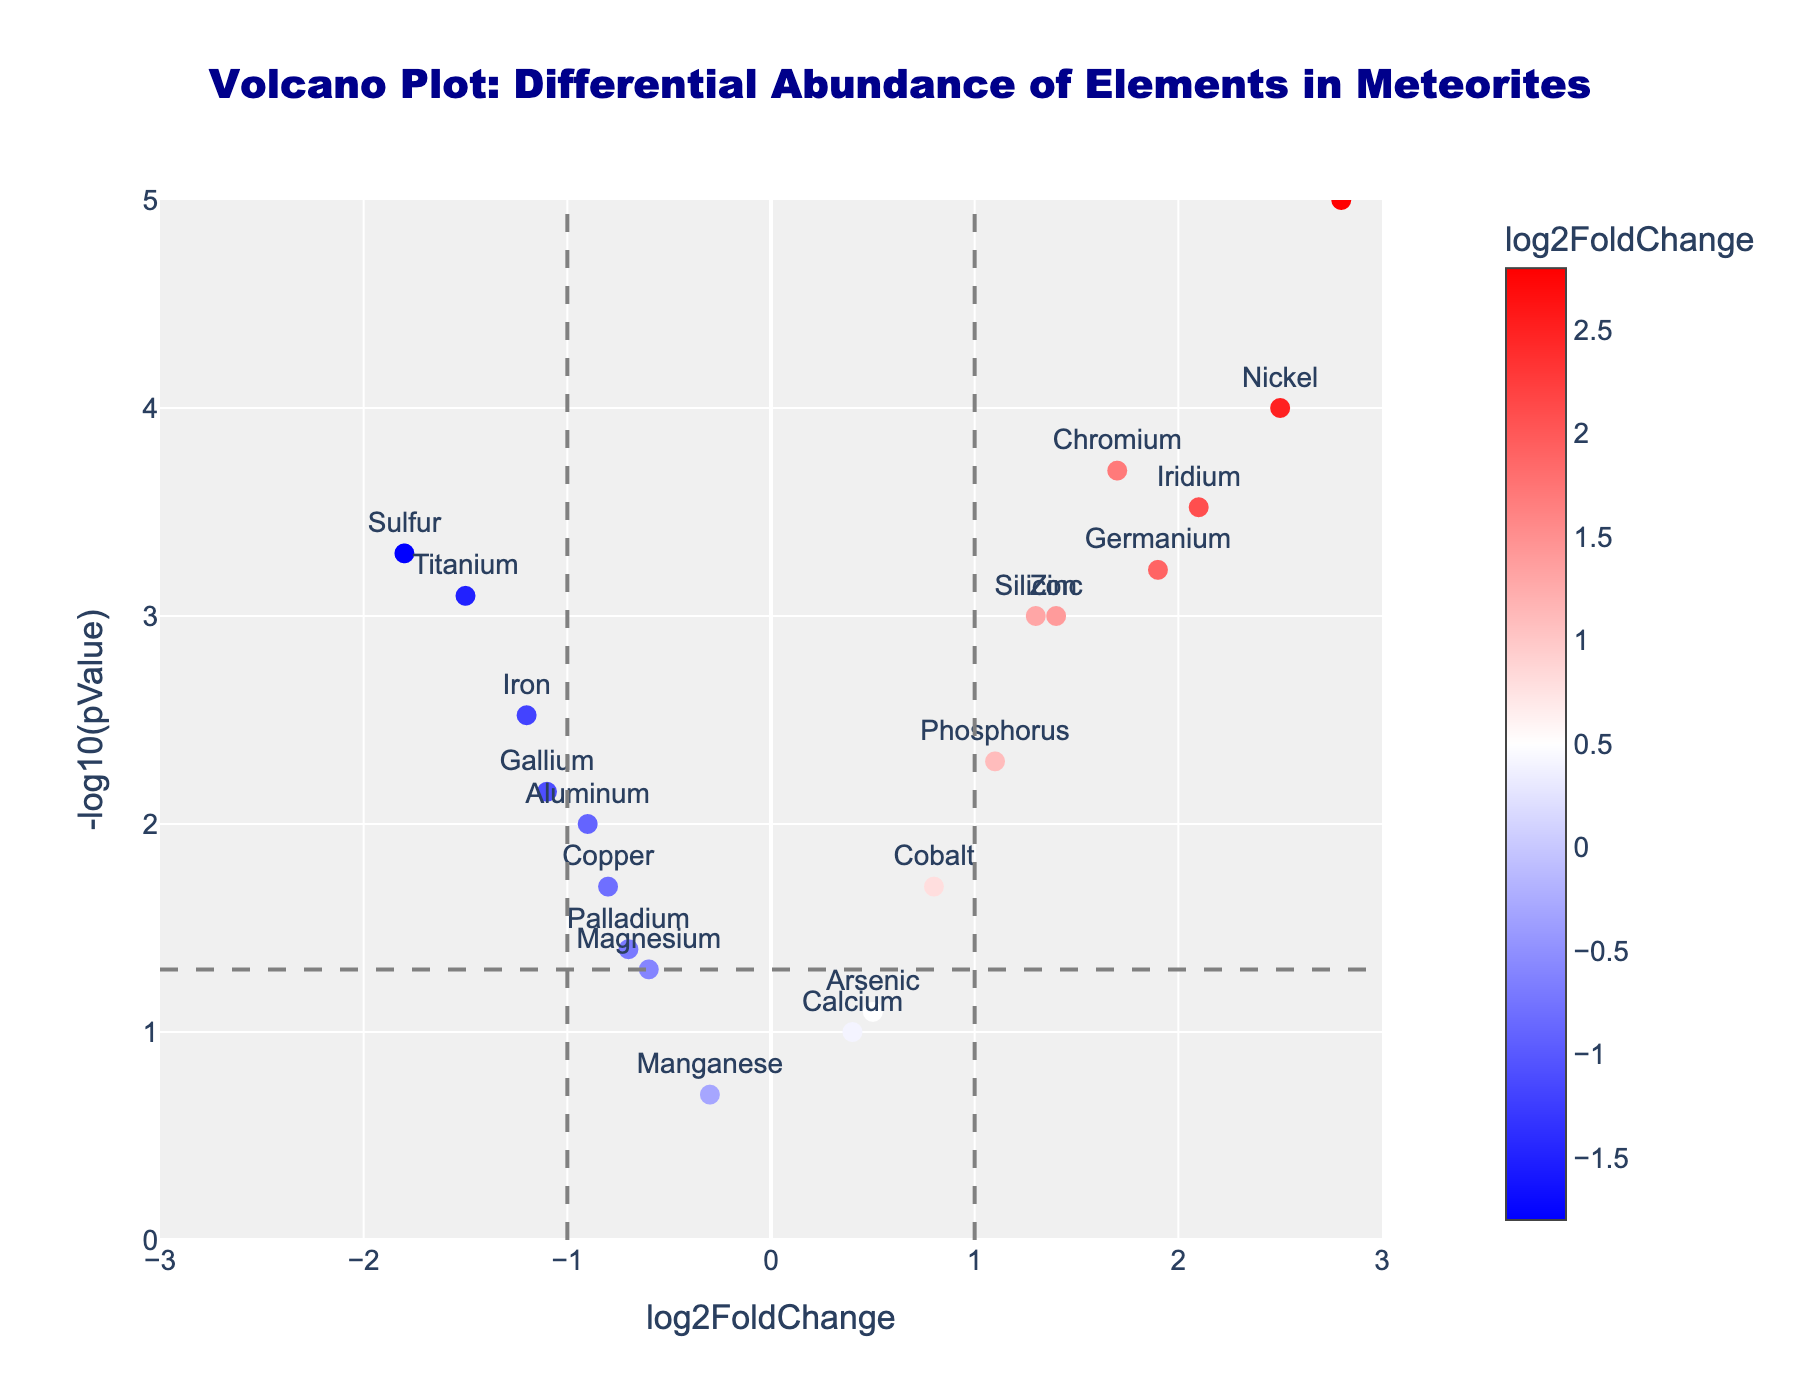What's the title of the figure? The title is prominently displayed at the top of the figure.
Answer: Volcano Plot: Differential Abundance of Elements in Meteorites What does the color of the markers represent? The color bar indicates that the color of the markers corresponds to the log2FoldChange values of the elements.
Answer: log2FoldChange Which element has the highest log2FoldChange? By observing the horizontal axis, the element with the highest value is identified as Platinum.
Answer: Platinum How is the -log10(pValue) for Iron compared to that for Nickel? By observing the vertical positions, Iron's -log10(pValue) is lower than Nickel's.
Answer: Iron < Nickel What's the log2FoldChange value for Silicon and Titanium? Refer to their respective positions on the horizontal axis. Silicon is approximately 1.3, and Titanium is about -1.5.
Answer: Silicon: 1.3, Titanium: -1.5 How many elements have a -log10(pValue) greater than 3? Locate the elements above the y-value of 3. Platinum, Nickel, Chromium, and Iridium qualify.
Answer: 4 Which element is closest to the horizontal and vertical intersection of log2FoldChange = 0 and -log10(pValue) = 1.3? Identify the point near the intersection. Magnesium appears to be closest.
Answer: Magnesium Between Zinc and Aluminum, which element has a higher statistical significance? Higher -log10(pValue) indicates higher significance. Zinc is higher than Aluminum.
Answer: Zinc Is there any element with a negative log2FoldChange but a high statistical significance (-log10(pValue) > 3)? Check markers in the left half of the plot (negative log2FoldChange) that are very high. Sulfur qualifies.
Answer: Sulfur What does a vertical line at log2FoldChange = 1 indicate? The vertical line might denote a threshold to distinguish significant changes in log2FoldChange.
Answer: Threshold for significant log2FoldChange 